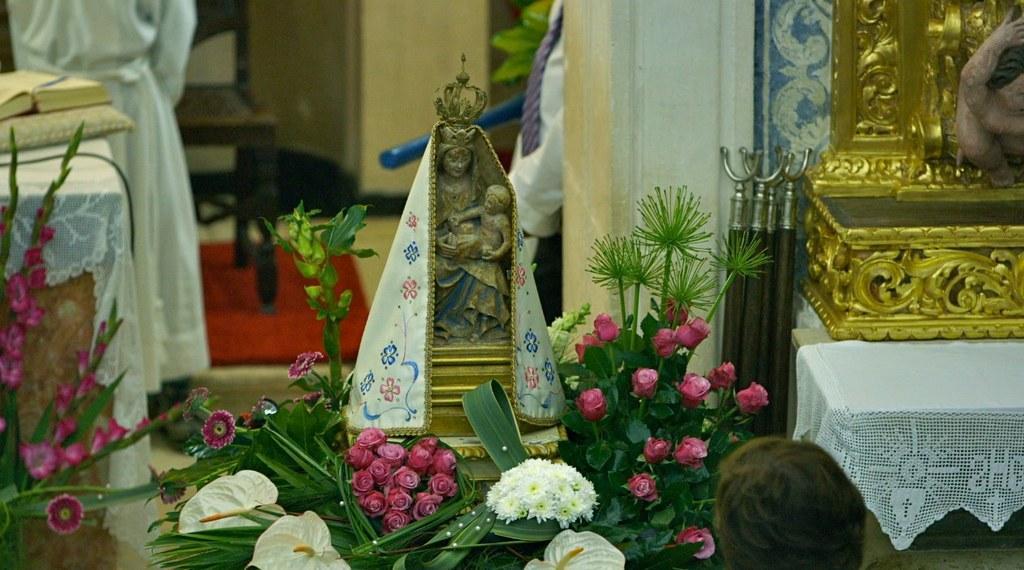How would you summarize this image in a sentence or two? In this image, there is a sculpture covered with a cloth. There are some flowers at the bottom of the image. There is box on the right side of the image. There is a table on the left side of the image contains a book. 